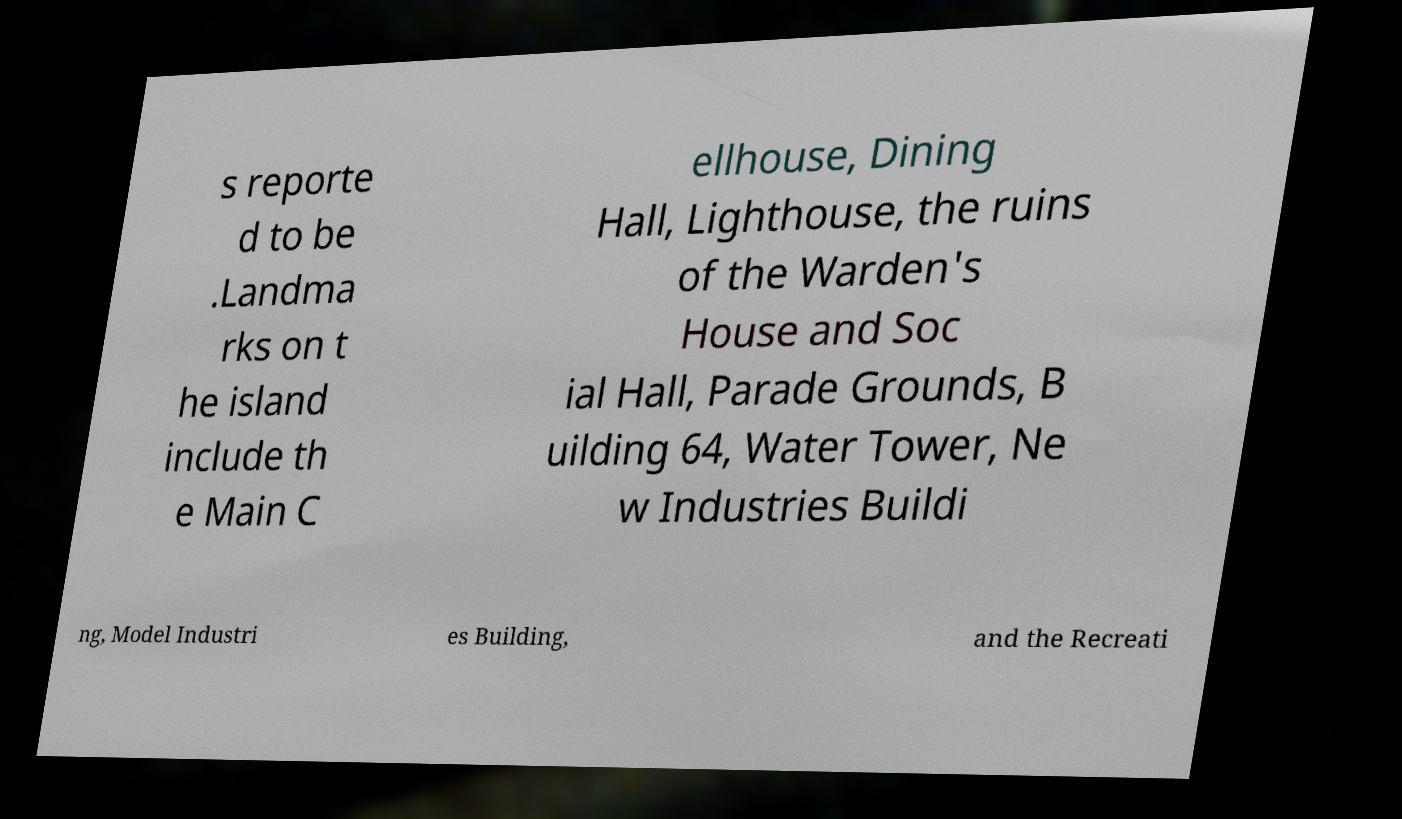I need the written content from this picture converted into text. Can you do that? s reporte d to be .Landma rks on t he island include th e Main C ellhouse, Dining Hall, Lighthouse, the ruins of the Warden's House and Soc ial Hall, Parade Grounds, B uilding 64, Water Tower, Ne w Industries Buildi ng, Model Industri es Building, and the Recreati 